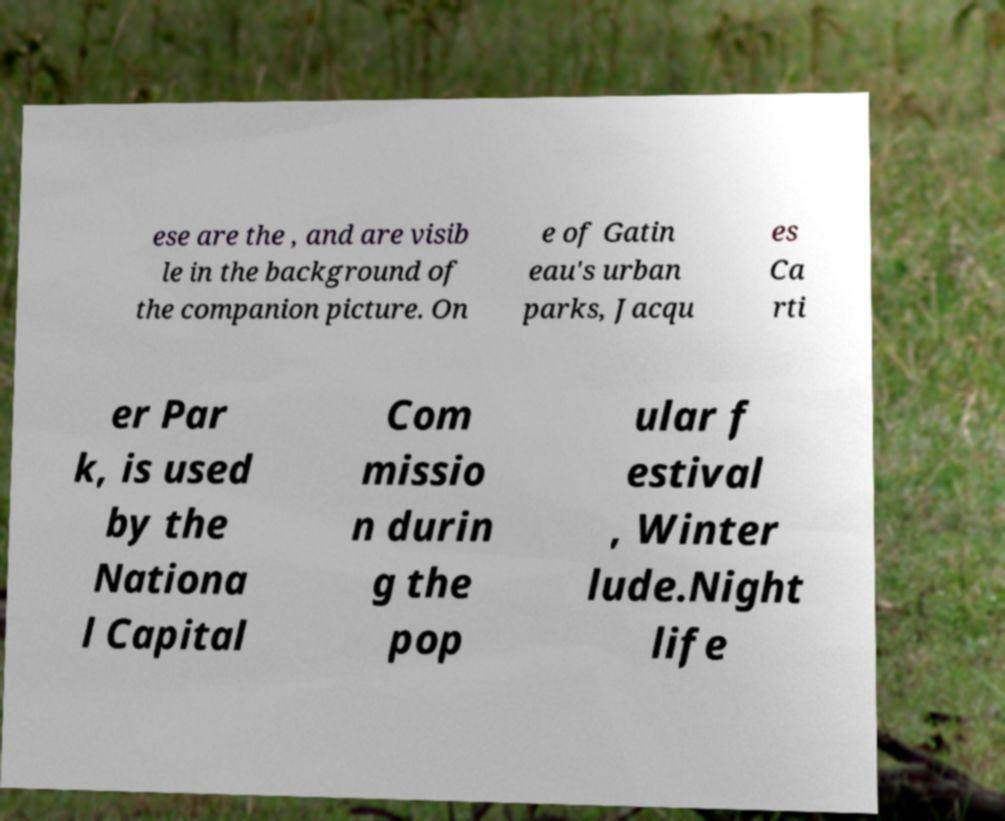Please identify and transcribe the text found in this image. ese are the , and are visib le in the background of the companion picture. On e of Gatin eau's urban parks, Jacqu es Ca rti er Par k, is used by the Nationa l Capital Com missio n durin g the pop ular f estival , Winter lude.Night life 